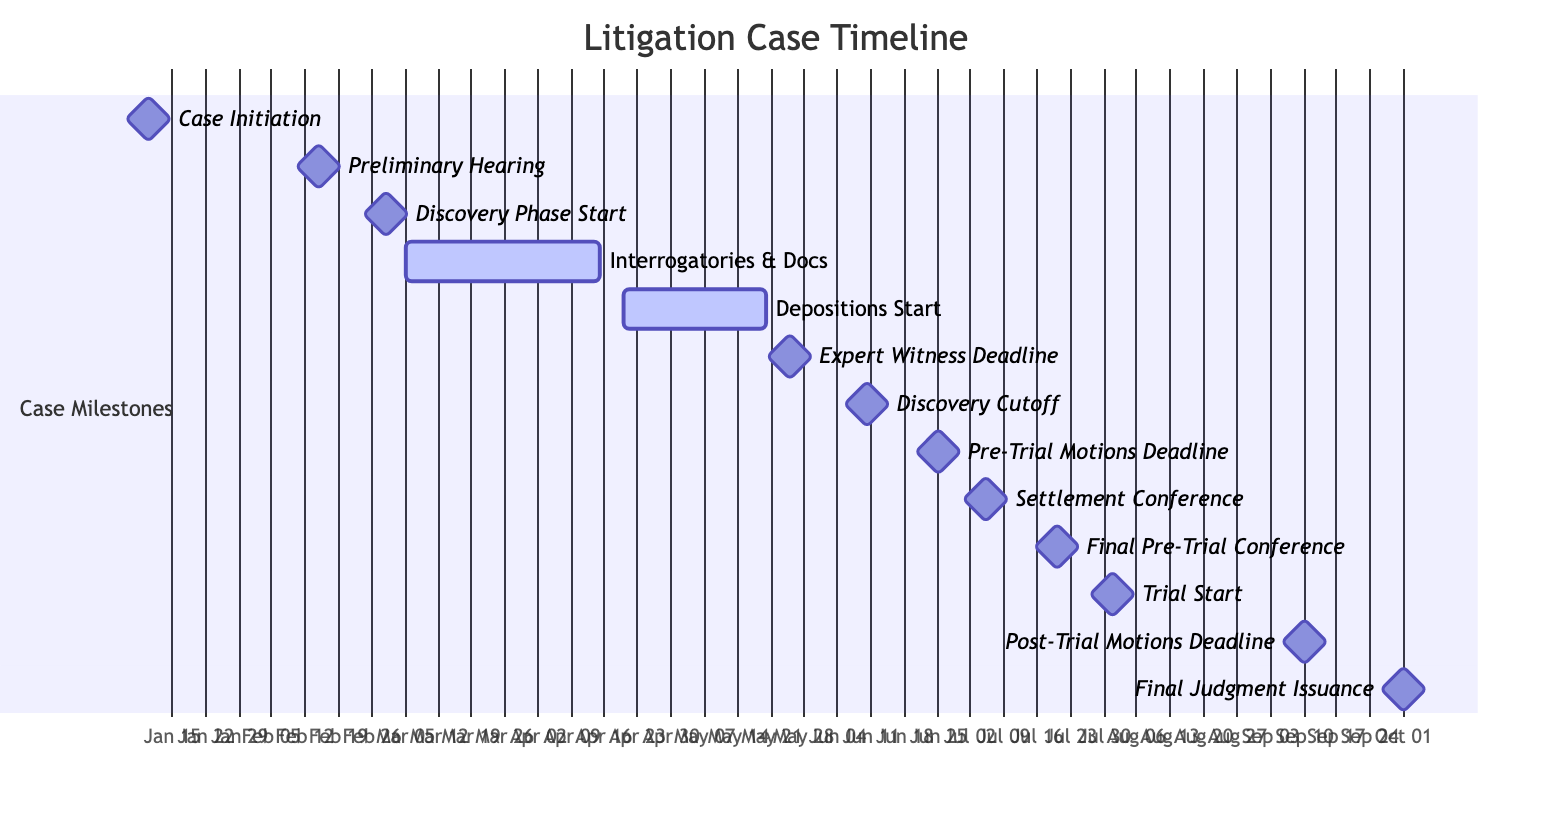What is the start date of the Discovery Phase? The milestone "Discovery Phase Start" indicates its starting date on the Gantt Chart is directly labeled with the date below it. This clearly shows that the Discovery Phase starts on March 1, 2023.
Answer: March 1, 2023 What is the milestone that occurs right before the Trial Start? By looking at the Gantt Chart, the trial start is scheduled for August 1, 2023. Checking the milestones that precede it, the "Final Pre-Trial Conference," which occurs on July 20, 2023, is the last milestone before the Trial Start.
Answer: Final Pre-Trial Conference How many days does the Interrogatories and Requests for Production of Documents phase last? The "Interrogatories and Requests for Production of Documents" phase starts on March 5, 2023, and ends on April 15, 2023. Calculating the duration involves counting the total days between these two dates, resulting in 41 days.
Answer: 41 days What is the only milestone occurring in June? Observing the chart, we can see there are three milestones in June. However, the question asks for the only milestone; the one clearly marked is "Discovery Cutoff," which occurs on June 10, 2023.
Answer: Discovery Cutoff How many key milestones are there in total between January and October? The timeline diagram lists a total of 13 milestones from the start date of January 10, 2023, to the final milestone on October 1, 2023. Counting each labeled milestone reveals the exact total of 13 key milestones.
Answer: 13 milestones What is the deadline for Expert Witness Disclosure? In the Gantt Chart, the "Expert Witness Disclosure Deadline" has a specific label indicating its date directly on March 25, 2023. Reading directly from the chart gives this precise date.
Answer: May 25, 2023 Which phase is the last active phase before trial? Looking at the timeline leading up to the trial starting on August 1, 2023, the last active phase before this point is the "Depositions Start," which begins on April 20, 2023, and ends on May 20, 2023.
Answer: Depositions Start What is the total duration from Case Initiation to Final Judgment Issuance? To find the total duration, we look at the start date of Case Initiation, January 10, 2023, and the end date of Final Judgment Issuance, October 1, 2023. Counting the time between these two dates provides the total duration of approximately 264 days.
Answer: 264 days 